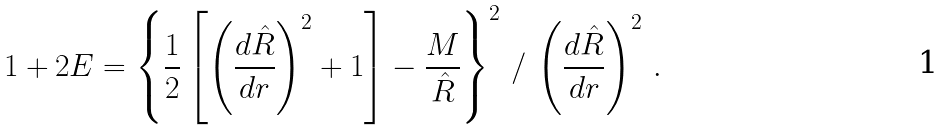Convert formula to latex. <formula><loc_0><loc_0><loc_500><loc_500>1 + 2 E = \left \{ \frac { 1 } { 2 } \left [ \left ( \frac { d \hat { R } } { d r } \right ) ^ { 2 } + 1 \right ] - \frac { M } { \hat { R } } \right \} ^ { 2 } \, / \, \left ( \frac { d \hat { R } } { d r } \right ) ^ { 2 } \, .</formula> 